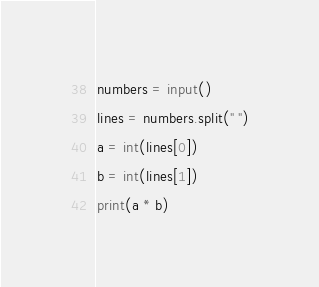<code> <loc_0><loc_0><loc_500><loc_500><_Python_>numbers = input()
lines = numbers.split(" ")
a = int(lines[0])
b = int(lines[1])
print(a * b)
</code> 